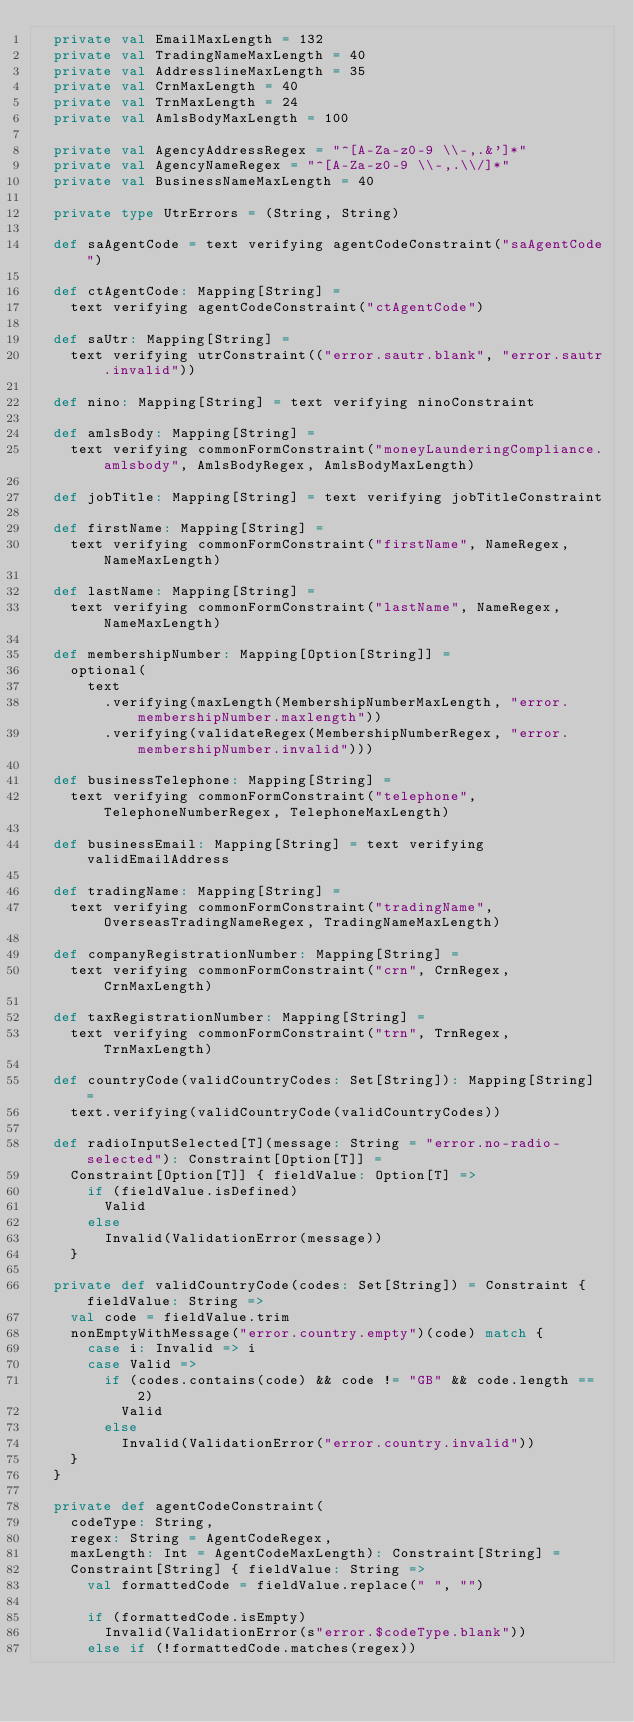<code> <loc_0><loc_0><loc_500><loc_500><_Scala_>  private val EmailMaxLength = 132
  private val TradingNameMaxLength = 40
  private val AddresslineMaxLength = 35
  private val CrnMaxLength = 40
  private val TrnMaxLength = 24
  private val AmlsBodyMaxLength = 100

  private val AgencyAddressRegex = "^[A-Za-z0-9 \\-,.&']*"
  private val AgencyNameRegex = "^[A-Za-z0-9 \\-,.\\/]*"
  private val BusinessNameMaxLength = 40

  private type UtrErrors = (String, String)

  def saAgentCode = text verifying agentCodeConstraint("saAgentCode")

  def ctAgentCode: Mapping[String] =
    text verifying agentCodeConstraint("ctAgentCode")

  def saUtr: Mapping[String] =
    text verifying utrConstraint(("error.sautr.blank", "error.sautr.invalid"))

  def nino: Mapping[String] = text verifying ninoConstraint

  def amlsBody: Mapping[String] =
    text verifying commonFormConstraint("moneyLaunderingCompliance.amlsbody", AmlsBodyRegex, AmlsBodyMaxLength)

  def jobTitle: Mapping[String] = text verifying jobTitleConstraint

  def firstName: Mapping[String] =
    text verifying commonFormConstraint("firstName", NameRegex, NameMaxLength)

  def lastName: Mapping[String] =
    text verifying commonFormConstraint("lastName", NameRegex, NameMaxLength)

  def membershipNumber: Mapping[Option[String]] =
    optional(
      text
        .verifying(maxLength(MembershipNumberMaxLength, "error.membershipNumber.maxlength"))
        .verifying(validateRegex(MembershipNumberRegex, "error.membershipNumber.invalid")))

  def businessTelephone: Mapping[String] =
    text verifying commonFormConstraint("telephone", TelephoneNumberRegex, TelephoneMaxLength)

  def businessEmail: Mapping[String] = text verifying validEmailAddress

  def tradingName: Mapping[String] =
    text verifying commonFormConstraint("tradingName", OverseasTradingNameRegex, TradingNameMaxLength)

  def companyRegistrationNumber: Mapping[String] =
    text verifying commonFormConstraint("crn", CrnRegex, CrnMaxLength)

  def taxRegistrationNumber: Mapping[String] =
    text verifying commonFormConstraint("trn", TrnRegex, TrnMaxLength)

  def countryCode(validCountryCodes: Set[String]): Mapping[String] =
    text.verifying(validCountryCode(validCountryCodes))

  def radioInputSelected[T](message: String = "error.no-radio-selected"): Constraint[Option[T]] =
    Constraint[Option[T]] { fieldValue: Option[T] =>
      if (fieldValue.isDefined)
        Valid
      else
        Invalid(ValidationError(message))
    }

  private def validCountryCode(codes: Set[String]) = Constraint { fieldValue: String =>
    val code = fieldValue.trim
    nonEmptyWithMessage("error.country.empty")(code) match {
      case i: Invalid => i
      case Valid =>
        if (codes.contains(code) && code != "GB" && code.length == 2)
          Valid
        else
          Invalid(ValidationError("error.country.invalid"))
    }
  }

  private def agentCodeConstraint(
    codeType: String,
    regex: String = AgentCodeRegex,
    maxLength: Int = AgentCodeMaxLength): Constraint[String] =
    Constraint[String] { fieldValue: String =>
      val formattedCode = fieldValue.replace(" ", "")

      if (formattedCode.isEmpty)
        Invalid(ValidationError(s"error.$codeType.blank"))
      else if (!formattedCode.matches(regex))</code> 